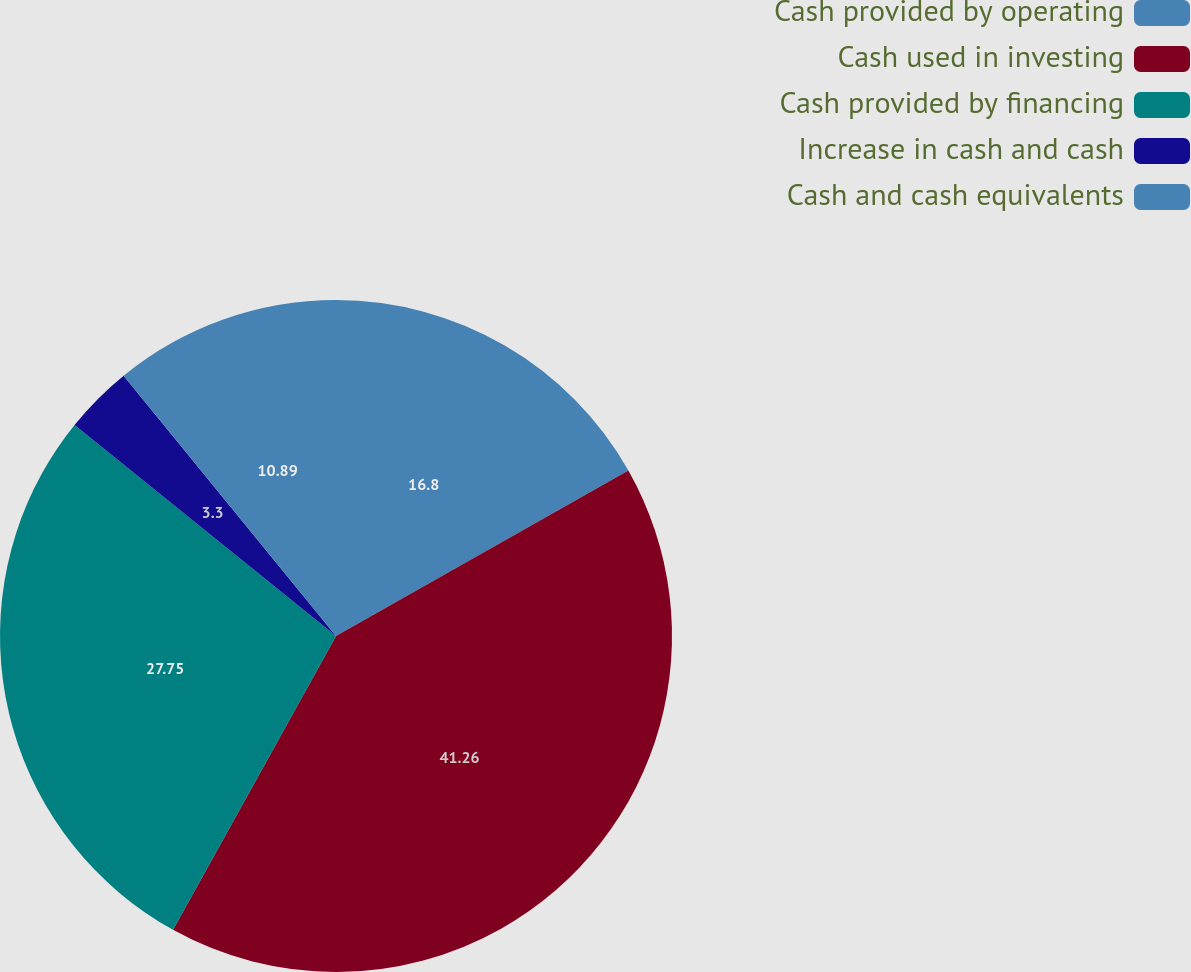<chart> <loc_0><loc_0><loc_500><loc_500><pie_chart><fcel>Cash provided by operating<fcel>Cash used in investing<fcel>Cash provided by financing<fcel>Increase in cash and cash<fcel>Cash and cash equivalents<nl><fcel>16.8%<fcel>41.26%<fcel>27.75%<fcel>3.3%<fcel>10.89%<nl></chart> 